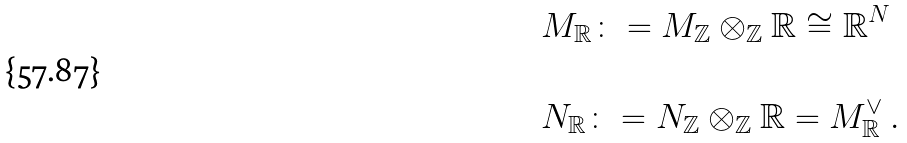<formula> <loc_0><loc_0><loc_500><loc_500>& M _ { \mathbb { R } } \colon = M _ { \mathbb { Z } } \otimes _ { \mathbb { Z } } \mathbb { R } \cong \mathbb { R } ^ { N } \\ \ \\ & N _ { \mathbb { R } } \colon = N _ { \mathbb { Z } } \otimes _ { \mathbb { Z } } \mathbb { R } = M _ { \mathbb { R } } ^ { \vee } \ .</formula> 